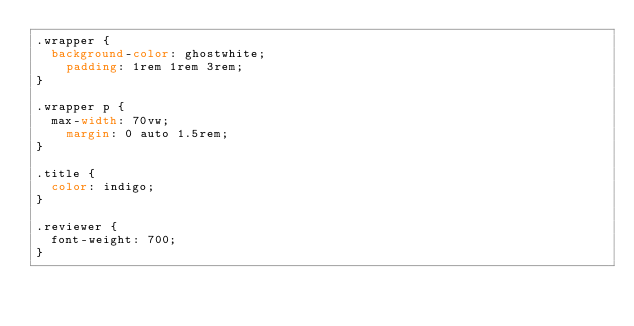<code> <loc_0><loc_0><loc_500><loc_500><_CSS_>.wrapper {
	background-color: ghostwhite;
    padding: 1rem 1rem 3rem;
}

.wrapper p {
	max-width: 70vw;
    margin: 0 auto 1.5rem;
}

.title {
	color: indigo;
}

.reviewer {
	font-weight: 700;
}</code> 